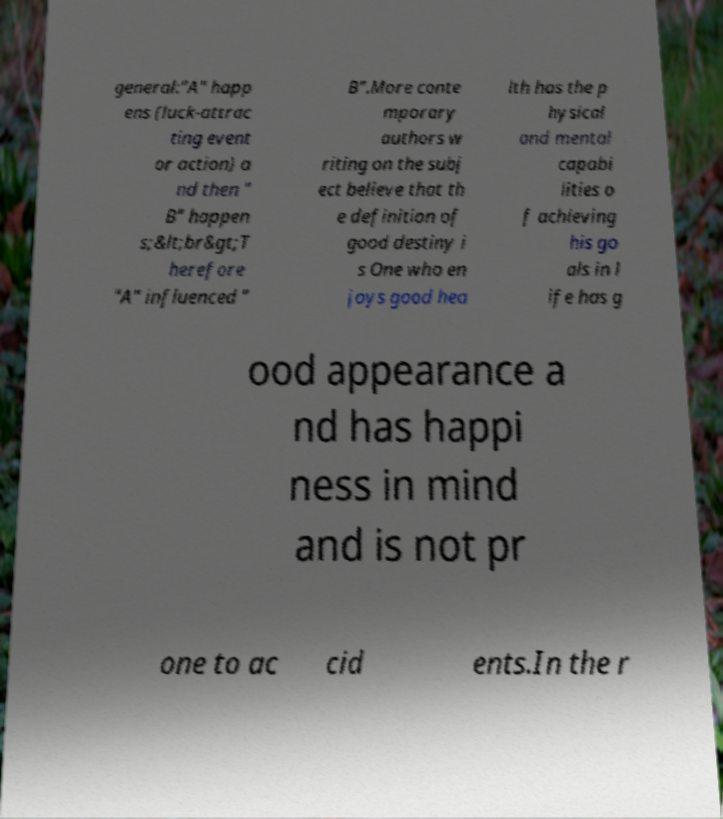What messages or text are displayed in this image? I need them in a readable, typed format. general:"A" happ ens (luck-attrac ting event or action) a nd then " B" happen s;&lt;br&gt;T herefore "A" influenced " B".More conte mporary authors w riting on the subj ect believe that th e definition of good destiny i s One who en joys good hea lth has the p hysical and mental capabi lities o f achieving his go als in l ife has g ood appearance a nd has happi ness in mind and is not pr one to ac cid ents.In the r 